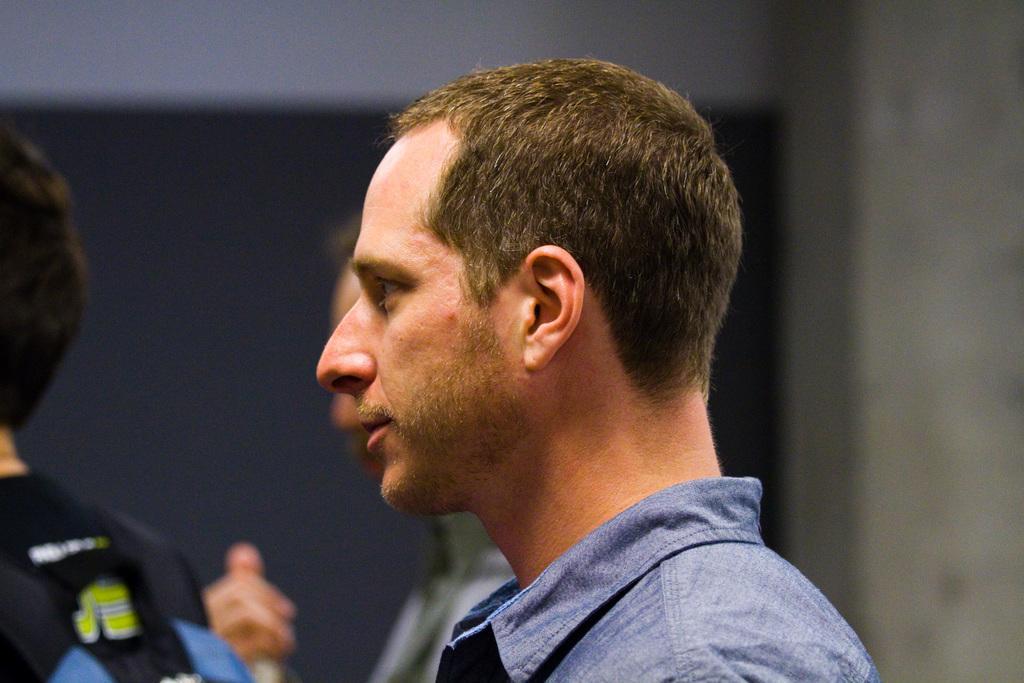In one or two sentences, can you explain what this image depicts? In the image there is a man in blue shirt standing, beside him there is another man standing and one in the front, in the back there is a wall. 